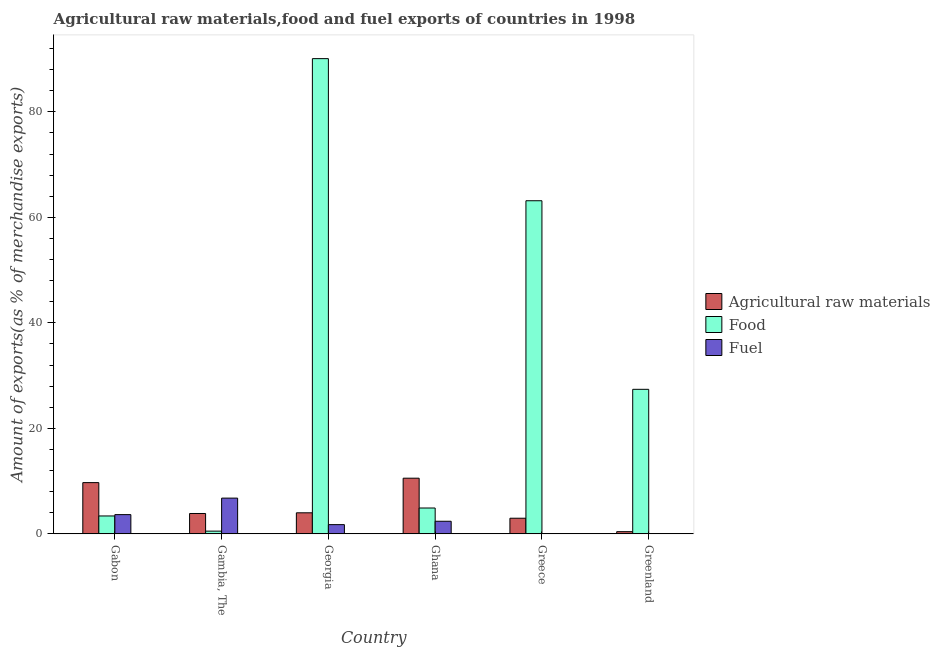Are the number of bars per tick equal to the number of legend labels?
Your answer should be very brief. Yes. Are the number of bars on each tick of the X-axis equal?
Your response must be concise. Yes. How many bars are there on the 4th tick from the left?
Provide a short and direct response. 3. What is the label of the 1st group of bars from the left?
Make the answer very short. Gabon. What is the percentage of raw materials exports in Gabon?
Provide a short and direct response. 9.71. Across all countries, what is the maximum percentage of raw materials exports?
Give a very brief answer. 10.55. Across all countries, what is the minimum percentage of food exports?
Keep it short and to the point. 0.52. In which country was the percentage of fuel exports maximum?
Offer a very short reply. Gambia, The. In which country was the percentage of raw materials exports minimum?
Offer a terse response. Greenland. What is the total percentage of raw materials exports in the graph?
Offer a very short reply. 31.5. What is the difference between the percentage of raw materials exports in Greece and that in Greenland?
Your answer should be very brief. 2.55. What is the difference between the percentage of fuel exports in Gambia, The and the percentage of food exports in Greece?
Offer a very short reply. -56.37. What is the average percentage of raw materials exports per country?
Ensure brevity in your answer.  5.25. What is the difference between the percentage of food exports and percentage of fuel exports in Greece?
Your response must be concise. 63.13. In how many countries, is the percentage of fuel exports greater than 4 %?
Give a very brief answer. 1. What is the ratio of the percentage of food exports in Georgia to that in Greece?
Your answer should be very brief. 1.43. Is the percentage of raw materials exports in Gabon less than that in Greenland?
Ensure brevity in your answer.  No. What is the difference between the highest and the second highest percentage of raw materials exports?
Provide a succinct answer. 0.84. What is the difference between the highest and the lowest percentage of food exports?
Your answer should be compact. 89.56. Is the sum of the percentage of fuel exports in Gabon and Greenland greater than the maximum percentage of food exports across all countries?
Your answer should be very brief. No. What does the 2nd bar from the left in Gabon represents?
Ensure brevity in your answer.  Food. What does the 1st bar from the right in Greece represents?
Your response must be concise. Fuel. Is it the case that in every country, the sum of the percentage of raw materials exports and percentage of food exports is greater than the percentage of fuel exports?
Provide a succinct answer. No. How many bars are there?
Offer a terse response. 18. How many countries are there in the graph?
Provide a succinct answer. 6. Are the values on the major ticks of Y-axis written in scientific E-notation?
Your answer should be compact. No. Does the graph contain any zero values?
Your response must be concise. No. How are the legend labels stacked?
Provide a succinct answer. Vertical. What is the title of the graph?
Your response must be concise. Agricultural raw materials,food and fuel exports of countries in 1998. Does "Other sectors" appear as one of the legend labels in the graph?
Provide a short and direct response. No. What is the label or title of the X-axis?
Give a very brief answer. Country. What is the label or title of the Y-axis?
Your response must be concise. Amount of exports(as % of merchandise exports). What is the Amount of exports(as % of merchandise exports) in Agricultural raw materials in Gabon?
Keep it short and to the point. 9.71. What is the Amount of exports(as % of merchandise exports) in Food in Gabon?
Your answer should be compact. 3.39. What is the Amount of exports(as % of merchandise exports) of Fuel in Gabon?
Provide a short and direct response. 3.65. What is the Amount of exports(as % of merchandise exports) of Agricultural raw materials in Gambia, The?
Your answer should be compact. 3.86. What is the Amount of exports(as % of merchandise exports) in Food in Gambia, The?
Make the answer very short. 0.52. What is the Amount of exports(as % of merchandise exports) of Fuel in Gambia, The?
Give a very brief answer. 6.78. What is the Amount of exports(as % of merchandise exports) of Agricultural raw materials in Georgia?
Make the answer very short. 3.99. What is the Amount of exports(as % of merchandise exports) in Food in Georgia?
Give a very brief answer. 90.08. What is the Amount of exports(as % of merchandise exports) in Fuel in Georgia?
Give a very brief answer. 1.75. What is the Amount of exports(as % of merchandise exports) in Agricultural raw materials in Ghana?
Offer a very short reply. 10.55. What is the Amount of exports(as % of merchandise exports) in Food in Ghana?
Offer a terse response. 4.9. What is the Amount of exports(as % of merchandise exports) of Fuel in Ghana?
Make the answer very short. 2.39. What is the Amount of exports(as % of merchandise exports) in Agricultural raw materials in Greece?
Provide a short and direct response. 2.96. What is the Amount of exports(as % of merchandise exports) in Food in Greece?
Provide a succinct answer. 63.14. What is the Amount of exports(as % of merchandise exports) of Fuel in Greece?
Ensure brevity in your answer.  0.01. What is the Amount of exports(as % of merchandise exports) in Agricultural raw materials in Greenland?
Provide a short and direct response. 0.42. What is the Amount of exports(as % of merchandise exports) in Food in Greenland?
Provide a short and direct response. 27.4. What is the Amount of exports(as % of merchandise exports) of Fuel in Greenland?
Offer a terse response. 0.06. Across all countries, what is the maximum Amount of exports(as % of merchandise exports) in Agricultural raw materials?
Offer a very short reply. 10.55. Across all countries, what is the maximum Amount of exports(as % of merchandise exports) in Food?
Your answer should be compact. 90.08. Across all countries, what is the maximum Amount of exports(as % of merchandise exports) of Fuel?
Ensure brevity in your answer.  6.78. Across all countries, what is the minimum Amount of exports(as % of merchandise exports) in Agricultural raw materials?
Your answer should be compact. 0.42. Across all countries, what is the minimum Amount of exports(as % of merchandise exports) of Food?
Your answer should be very brief. 0.52. Across all countries, what is the minimum Amount of exports(as % of merchandise exports) in Fuel?
Your response must be concise. 0.01. What is the total Amount of exports(as % of merchandise exports) of Agricultural raw materials in the graph?
Your answer should be very brief. 31.5. What is the total Amount of exports(as % of merchandise exports) in Food in the graph?
Your answer should be compact. 189.43. What is the total Amount of exports(as % of merchandise exports) of Fuel in the graph?
Offer a very short reply. 14.63. What is the difference between the Amount of exports(as % of merchandise exports) in Agricultural raw materials in Gabon and that in Gambia, The?
Your answer should be compact. 5.85. What is the difference between the Amount of exports(as % of merchandise exports) in Food in Gabon and that in Gambia, The?
Your answer should be compact. 2.88. What is the difference between the Amount of exports(as % of merchandise exports) of Fuel in Gabon and that in Gambia, The?
Your answer should be very brief. -3.13. What is the difference between the Amount of exports(as % of merchandise exports) of Agricultural raw materials in Gabon and that in Georgia?
Your answer should be compact. 5.72. What is the difference between the Amount of exports(as % of merchandise exports) in Food in Gabon and that in Georgia?
Offer a very short reply. -86.69. What is the difference between the Amount of exports(as % of merchandise exports) in Fuel in Gabon and that in Georgia?
Your response must be concise. 1.9. What is the difference between the Amount of exports(as % of merchandise exports) in Agricultural raw materials in Gabon and that in Ghana?
Offer a very short reply. -0.84. What is the difference between the Amount of exports(as % of merchandise exports) of Food in Gabon and that in Ghana?
Your answer should be very brief. -1.51. What is the difference between the Amount of exports(as % of merchandise exports) in Fuel in Gabon and that in Ghana?
Offer a very short reply. 1.26. What is the difference between the Amount of exports(as % of merchandise exports) in Agricultural raw materials in Gabon and that in Greece?
Provide a succinct answer. 6.75. What is the difference between the Amount of exports(as % of merchandise exports) in Food in Gabon and that in Greece?
Offer a terse response. -59.75. What is the difference between the Amount of exports(as % of merchandise exports) of Fuel in Gabon and that in Greece?
Your answer should be very brief. 3.63. What is the difference between the Amount of exports(as % of merchandise exports) in Agricultural raw materials in Gabon and that in Greenland?
Offer a very short reply. 9.3. What is the difference between the Amount of exports(as % of merchandise exports) of Food in Gabon and that in Greenland?
Your answer should be very brief. -24. What is the difference between the Amount of exports(as % of merchandise exports) in Fuel in Gabon and that in Greenland?
Provide a short and direct response. 3.59. What is the difference between the Amount of exports(as % of merchandise exports) of Agricultural raw materials in Gambia, The and that in Georgia?
Keep it short and to the point. -0.13. What is the difference between the Amount of exports(as % of merchandise exports) of Food in Gambia, The and that in Georgia?
Provide a succinct answer. -89.56. What is the difference between the Amount of exports(as % of merchandise exports) in Fuel in Gambia, The and that in Georgia?
Provide a succinct answer. 5.03. What is the difference between the Amount of exports(as % of merchandise exports) of Agricultural raw materials in Gambia, The and that in Ghana?
Ensure brevity in your answer.  -6.69. What is the difference between the Amount of exports(as % of merchandise exports) in Food in Gambia, The and that in Ghana?
Your response must be concise. -4.39. What is the difference between the Amount of exports(as % of merchandise exports) of Fuel in Gambia, The and that in Ghana?
Give a very brief answer. 4.39. What is the difference between the Amount of exports(as % of merchandise exports) of Agricultural raw materials in Gambia, The and that in Greece?
Your answer should be compact. 0.9. What is the difference between the Amount of exports(as % of merchandise exports) in Food in Gambia, The and that in Greece?
Keep it short and to the point. -62.63. What is the difference between the Amount of exports(as % of merchandise exports) in Fuel in Gambia, The and that in Greece?
Your answer should be compact. 6.76. What is the difference between the Amount of exports(as % of merchandise exports) in Agricultural raw materials in Gambia, The and that in Greenland?
Ensure brevity in your answer.  3.45. What is the difference between the Amount of exports(as % of merchandise exports) in Food in Gambia, The and that in Greenland?
Keep it short and to the point. -26.88. What is the difference between the Amount of exports(as % of merchandise exports) in Fuel in Gambia, The and that in Greenland?
Your response must be concise. 6.72. What is the difference between the Amount of exports(as % of merchandise exports) of Agricultural raw materials in Georgia and that in Ghana?
Your response must be concise. -6.56. What is the difference between the Amount of exports(as % of merchandise exports) of Food in Georgia and that in Ghana?
Ensure brevity in your answer.  85.18. What is the difference between the Amount of exports(as % of merchandise exports) in Fuel in Georgia and that in Ghana?
Your response must be concise. -0.64. What is the difference between the Amount of exports(as % of merchandise exports) in Agricultural raw materials in Georgia and that in Greece?
Your answer should be compact. 1.03. What is the difference between the Amount of exports(as % of merchandise exports) of Food in Georgia and that in Greece?
Provide a short and direct response. 26.94. What is the difference between the Amount of exports(as % of merchandise exports) of Fuel in Georgia and that in Greece?
Provide a succinct answer. 1.74. What is the difference between the Amount of exports(as % of merchandise exports) in Agricultural raw materials in Georgia and that in Greenland?
Your answer should be very brief. 3.58. What is the difference between the Amount of exports(as % of merchandise exports) in Food in Georgia and that in Greenland?
Your answer should be very brief. 62.68. What is the difference between the Amount of exports(as % of merchandise exports) in Fuel in Georgia and that in Greenland?
Your answer should be compact. 1.69. What is the difference between the Amount of exports(as % of merchandise exports) of Agricultural raw materials in Ghana and that in Greece?
Your answer should be compact. 7.59. What is the difference between the Amount of exports(as % of merchandise exports) of Food in Ghana and that in Greece?
Keep it short and to the point. -58.24. What is the difference between the Amount of exports(as % of merchandise exports) of Fuel in Ghana and that in Greece?
Your response must be concise. 2.37. What is the difference between the Amount of exports(as % of merchandise exports) of Agricultural raw materials in Ghana and that in Greenland?
Make the answer very short. 10.13. What is the difference between the Amount of exports(as % of merchandise exports) in Food in Ghana and that in Greenland?
Your response must be concise. -22.5. What is the difference between the Amount of exports(as % of merchandise exports) of Fuel in Ghana and that in Greenland?
Give a very brief answer. 2.33. What is the difference between the Amount of exports(as % of merchandise exports) of Agricultural raw materials in Greece and that in Greenland?
Make the answer very short. 2.55. What is the difference between the Amount of exports(as % of merchandise exports) of Food in Greece and that in Greenland?
Keep it short and to the point. 35.75. What is the difference between the Amount of exports(as % of merchandise exports) of Fuel in Greece and that in Greenland?
Give a very brief answer. -0.04. What is the difference between the Amount of exports(as % of merchandise exports) in Agricultural raw materials in Gabon and the Amount of exports(as % of merchandise exports) in Food in Gambia, The?
Your answer should be compact. 9.2. What is the difference between the Amount of exports(as % of merchandise exports) of Agricultural raw materials in Gabon and the Amount of exports(as % of merchandise exports) of Fuel in Gambia, The?
Offer a terse response. 2.94. What is the difference between the Amount of exports(as % of merchandise exports) in Food in Gabon and the Amount of exports(as % of merchandise exports) in Fuel in Gambia, The?
Provide a succinct answer. -3.38. What is the difference between the Amount of exports(as % of merchandise exports) of Agricultural raw materials in Gabon and the Amount of exports(as % of merchandise exports) of Food in Georgia?
Provide a short and direct response. -80.37. What is the difference between the Amount of exports(as % of merchandise exports) of Agricultural raw materials in Gabon and the Amount of exports(as % of merchandise exports) of Fuel in Georgia?
Give a very brief answer. 7.96. What is the difference between the Amount of exports(as % of merchandise exports) in Food in Gabon and the Amount of exports(as % of merchandise exports) in Fuel in Georgia?
Ensure brevity in your answer.  1.64. What is the difference between the Amount of exports(as % of merchandise exports) in Agricultural raw materials in Gabon and the Amount of exports(as % of merchandise exports) in Food in Ghana?
Ensure brevity in your answer.  4.81. What is the difference between the Amount of exports(as % of merchandise exports) in Agricultural raw materials in Gabon and the Amount of exports(as % of merchandise exports) in Fuel in Ghana?
Provide a succinct answer. 7.32. What is the difference between the Amount of exports(as % of merchandise exports) in Food in Gabon and the Amount of exports(as % of merchandise exports) in Fuel in Ghana?
Your answer should be very brief. 1. What is the difference between the Amount of exports(as % of merchandise exports) of Agricultural raw materials in Gabon and the Amount of exports(as % of merchandise exports) of Food in Greece?
Provide a short and direct response. -53.43. What is the difference between the Amount of exports(as % of merchandise exports) in Agricultural raw materials in Gabon and the Amount of exports(as % of merchandise exports) in Fuel in Greece?
Your answer should be compact. 9.7. What is the difference between the Amount of exports(as % of merchandise exports) in Food in Gabon and the Amount of exports(as % of merchandise exports) in Fuel in Greece?
Provide a short and direct response. 3.38. What is the difference between the Amount of exports(as % of merchandise exports) of Agricultural raw materials in Gabon and the Amount of exports(as % of merchandise exports) of Food in Greenland?
Your response must be concise. -17.68. What is the difference between the Amount of exports(as % of merchandise exports) of Agricultural raw materials in Gabon and the Amount of exports(as % of merchandise exports) of Fuel in Greenland?
Provide a short and direct response. 9.66. What is the difference between the Amount of exports(as % of merchandise exports) in Food in Gabon and the Amount of exports(as % of merchandise exports) in Fuel in Greenland?
Ensure brevity in your answer.  3.34. What is the difference between the Amount of exports(as % of merchandise exports) of Agricultural raw materials in Gambia, The and the Amount of exports(as % of merchandise exports) of Food in Georgia?
Give a very brief answer. -86.22. What is the difference between the Amount of exports(as % of merchandise exports) of Agricultural raw materials in Gambia, The and the Amount of exports(as % of merchandise exports) of Fuel in Georgia?
Give a very brief answer. 2.11. What is the difference between the Amount of exports(as % of merchandise exports) of Food in Gambia, The and the Amount of exports(as % of merchandise exports) of Fuel in Georgia?
Keep it short and to the point. -1.23. What is the difference between the Amount of exports(as % of merchandise exports) in Agricultural raw materials in Gambia, The and the Amount of exports(as % of merchandise exports) in Food in Ghana?
Offer a terse response. -1.04. What is the difference between the Amount of exports(as % of merchandise exports) of Agricultural raw materials in Gambia, The and the Amount of exports(as % of merchandise exports) of Fuel in Ghana?
Provide a succinct answer. 1.47. What is the difference between the Amount of exports(as % of merchandise exports) of Food in Gambia, The and the Amount of exports(as % of merchandise exports) of Fuel in Ghana?
Make the answer very short. -1.87. What is the difference between the Amount of exports(as % of merchandise exports) of Agricultural raw materials in Gambia, The and the Amount of exports(as % of merchandise exports) of Food in Greece?
Your response must be concise. -59.28. What is the difference between the Amount of exports(as % of merchandise exports) of Agricultural raw materials in Gambia, The and the Amount of exports(as % of merchandise exports) of Fuel in Greece?
Keep it short and to the point. 3.85. What is the difference between the Amount of exports(as % of merchandise exports) in Food in Gambia, The and the Amount of exports(as % of merchandise exports) in Fuel in Greece?
Your response must be concise. 0.5. What is the difference between the Amount of exports(as % of merchandise exports) of Agricultural raw materials in Gambia, The and the Amount of exports(as % of merchandise exports) of Food in Greenland?
Your response must be concise. -23.54. What is the difference between the Amount of exports(as % of merchandise exports) in Agricultural raw materials in Gambia, The and the Amount of exports(as % of merchandise exports) in Fuel in Greenland?
Your answer should be compact. 3.81. What is the difference between the Amount of exports(as % of merchandise exports) in Food in Gambia, The and the Amount of exports(as % of merchandise exports) in Fuel in Greenland?
Give a very brief answer. 0.46. What is the difference between the Amount of exports(as % of merchandise exports) of Agricultural raw materials in Georgia and the Amount of exports(as % of merchandise exports) of Food in Ghana?
Your answer should be very brief. -0.91. What is the difference between the Amount of exports(as % of merchandise exports) of Agricultural raw materials in Georgia and the Amount of exports(as % of merchandise exports) of Fuel in Ghana?
Your response must be concise. 1.6. What is the difference between the Amount of exports(as % of merchandise exports) of Food in Georgia and the Amount of exports(as % of merchandise exports) of Fuel in Ghana?
Your answer should be compact. 87.69. What is the difference between the Amount of exports(as % of merchandise exports) in Agricultural raw materials in Georgia and the Amount of exports(as % of merchandise exports) in Food in Greece?
Keep it short and to the point. -59.15. What is the difference between the Amount of exports(as % of merchandise exports) of Agricultural raw materials in Georgia and the Amount of exports(as % of merchandise exports) of Fuel in Greece?
Your answer should be very brief. 3.98. What is the difference between the Amount of exports(as % of merchandise exports) in Food in Georgia and the Amount of exports(as % of merchandise exports) in Fuel in Greece?
Give a very brief answer. 90.07. What is the difference between the Amount of exports(as % of merchandise exports) in Agricultural raw materials in Georgia and the Amount of exports(as % of merchandise exports) in Food in Greenland?
Your answer should be compact. -23.41. What is the difference between the Amount of exports(as % of merchandise exports) in Agricultural raw materials in Georgia and the Amount of exports(as % of merchandise exports) in Fuel in Greenland?
Give a very brief answer. 3.93. What is the difference between the Amount of exports(as % of merchandise exports) in Food in Georgia and the Amount of exports(as % of merchandise exports) in Fuel in Greenland?
Your answer should be very brief. 90.02. What is the difference between the Amount of exports(as % of merchandise exports) in Agricultural raw materials in Ghana and the Amount of exports(as % of merchandise exports) in Food in Greece?
Ensure brevity in your answer.  -52.59. What is the difference between the Amount of exports(as % of merchandise exports) in Agricultural raw materials in Ghana and the Amount of exports(as % of merchandise exports) in Fuel in Greece?
Your answer should be very brief. 10.54. What is the difference between the Amount of exports(as % of merchandise exports) of Food in Ghana and the Amount of exports(as % of merchandise exports) of Fuel in Greece?
Your answer should be compact. 4.89. What is the difference between the Amount of exports(as % of merchandise exports) of Agricultural raw materials in Ghana and the Amount of exports(as % of merchandise exports) of Food in Greenland?
Ensure brevity in your answer.  -16.85. What is the difference between the Amount of exports(as % of merchandise exports) in Agricultural raw materials in Ghana and the Amount of exports(as % of merchandise exports) in Fuel in Greenland?
Keep it short and to the point. 10.49. What is the difference between the Amount of exports(as % of merchandise exports) in Food in Ghana and the Amount of exports(as % of merchandise exports) in Fuel in Greenland?
Offer a very short reply. 4.85. What is the difference between the Amount of exports(as % of merchandise exports) in Agricultural raw materials in Greece and the Amount of exports(as % of merchandise exports) in Food in Greenland?
Make the answer very short. -24.43. What is the difference between the Amount of exports(as % of merchandise exports) of Agricultural raw materials in Greece and the Amount of exports(as % of merchandise exports) of Fuel in Greenland?
Provide a succinct answer. 2.91. What is the difference between the Amount of exports(as % of merchandise exports) in Food in Greece and the Amount of exports(as % of merchandise exports) in Fuel in Greenland?
Provide a succinct answer. 63.09. What is the average Amount of exports(as % of merchandise exports) in Agricultural raw materials per country?
Provide a short and direct response. 5.25. What is the average Amount of exports(as % of merchandise exports) in Food per country?
Keep it short and to the point. 31.57. What is the average Amount of exports(as % of merchandise exports) of Fuel per country?
Your response must be concise. 2.44. What is the difference between the Amount of exports(as % of merchandise exports) in Agricultural raw materials and Amount of exports(as % of merchandise exports) in Food in Gabon?
Offer a terse response. 6.32. What is the difference between the Amount of exports(as % of merchandise exports) of Agricultural raw materials and Amount of exports(as % of merchandise exports) of Fuel in Gabon?
Offer a very short reply. 6.07. What is the difference between the Amount of exports(as % of merchandise exports) of Food and Amount of exports(as % of merchandise exports) of Fuel in Gabon?
Provide a succinct answer. -0.25. What is the difference between the Amount of exports(as % of merchandise exports) in Agricultural raw materials and Amount of exports(as % of merchandise exports) in Food in Gambia, The?
Ensure brevity in your answer.  3.35. What is the difference between the Amount of exports(as % of merchandise exports) of Agricultural raw materials and Amount of exports(as % of merchandise exports) of Fuel in Gambia, The?
Provide a short and direct response. -2.91. What is the difference between the Amount of exports(as % of merchandise exports) of Food and Amount of exports(as % of merchandise exports) of Fuel in Gambia, The?
Offer a terse response. -6.26. What is the difference between the Amount of exports(as % of merchandise exports) of Agricultural raw materials and Amount of exports(as % of merchandise exports) of Food in Georgia?
Offer a terse response. -86.09. What is the difference between the Amount of exports(as % of merchandise exports) in Agricultural raw materials and Amount of exports(as % of merchandise exports) in Fuel in Georgia?
Provide a succinct answer. 2.24. What is the difference between the Amount of exports(as % of merchandise exports) in Food and Amount of exports(as % of merchandise exports) in Fuel in Georgia?
Make the answer very short. 88.33. What is the difference between the Amount of exports(as % of merchandise exports) in Agricultural raw materials and Amount of exports(as % of merchandise exports) in Food in Ghana?
Ensure brevity in your answer.  5.65. What is the difference between the Amount of exports(as % of merchandise exports) of Agricultural raw materials and Amount of exports(as % of merchandise exports) of Fuel in Ghana?
Provide a succinct answer. 8.16. What is the difference between the Amount of exports(as % of merchandise exports) of Food and Amount of exports(as % of merchandise exports) of Fuel in Ghana?
Make the answer very short. 2.51. What is the difference between the Amount of exports(as % of merchandise exports) of Agricultural raw materials and Amount of exports(as % of merchandise exports) of Food in Greece?
Offer a terse response. -60.18. What is the difference between the Amount of exports(as % of merchandise exports) in Agricultural raw materials and Amount of exports(as % of merchandise exports) in Fuel in Greece?
Provide a short and direct response. 2.95. What is the difference between the Amount of exports(as % of merchandise exports) of Food and Amount of exports(as % of merchandise exports) of Fuel in Greece?
Give a very brief answer. 63.13. What is the difference between the Amount of exports(as % of merchandise exports) of Agricultural raw materials and Amount of exports(as % of merchandise exports) of Food in Greenland?
Your response must be concise. -26.98. What is the difference between the Amount of exports(as % of merchandise exports) in Agricultural raw materials and Amount of exports(as % of merchandise exports) in Fuel in Greenland?
Ensure brevity in your answer.  0.36. What is the difference between the Amount of exports(as % of merchandise exports) of Food and Amount of exports(as % of merchandise exports) of Fuel in Greenland?
Your answer should be compact. 27.34. What is the ratio of the Amount of exports(as % of merchandise exports) of Agricultural raw materials in Gabon to that in Gambia, The?
Offer a terse response. 2.52. What is the ratio of the Amount of exports(as % of merchandise exports) in Food in Gabon to that in Gambia, The?
Keep it short and to the point. 6.58. What is the ratio of the Amount of exports(as % of merchandise exports) in Fuel in Gabon to that in Gambia, The?
Provide a short and direct response. 0.54. What is the ratio of the Amount of exports(as % of merchandise exports) of Agricultural raw materials in Gabon to that in Georgia?
Keep it short and to the point. 2.43. What is the ratio of the Amount of exports(as % of merchandise exports) in Food in Gabon to that in Georgia?
Make the answer very short. 0.04. What is the ratio of the Amount of exports(as % of merchandise exports) in Fuel in Gabon to that in Georgia?
Keep it short and to the point. 2.08. What is the ratio of the Amount of exports(as % of merchandise exports) in Agricultural raw materials in Gabon to that in Ghana?
Your answer should be very brief. 0.92. What is the ratio of the Amount of exports(as % of merchandise exports) in Food in Gabon to that in Ghana?
Your answer should be compact. 0.69. What is the ratio of the Amount of exports(as % of merchandise exports) in Fuel in Gabon to that in Ghana?
Your answer should be compact. 1.53. What is the ratio of the Amount of exports(as % of merchandise exports) in Agricultural raw materials in Gabon to that in Greece?
Offer a terse response. 3.28. What is the ratio of the Amount of exports(as % of merchandise exports) in Food in Gabon to that in Greece?
Give a very brief answer. 0.05. What is the ratio of the Amount of exports(as % of merchandise exports) in Fuel in Gabon to that in Greece?
Provide a short and direct response. 267.36. What is the ratio of the Amount of exports(as % of merchandise exports) in Agricultural raw materials in Gabon to that in Greenland?
Your response must be concise. 23.37. What is the ratio of the Amount of exports(as % of merchandise exports) of Food in Gabon to that in Greenland?
Your answer should be compact. 0.12. What is the ratio of the Amount of exports(as % of merchandise exports) of Fuel in Gabon to that in Greenland?
Your response must be concise. 64.36. What is the ratio of the Amount of exports(as % of merchandise exports) of Agricultural raw materials in Gambia, The to that in Georgia?
Offer a terse response. 0.97. What is the ratio of the Amount of exports(as % of merchandise exports) of Food in Gambia, The to that in Georgia?
Offer a terse response. 0.01. What is the ratio of the Amount of exports(as % of merchandise exports) of Fuel in Gambia, The to that in Georgia?
Offer a very short reply. 3.87. What is the ratio of the Amount of exports(as % of merchandise exports) in Agricultural raw materials in Gambia, The to that in Ghana?
Offer a terse response. 0.37. What is the ratio of the Amount of exports(as % of merchandise exports) in Food in Gambia, The to that in Ghana?
Give a very brief answer. 0.11. What is the ratio of the Amount of exports(as % of merchandise exports) in Fuel in Gambia, The to that in Ghana?
Ensure brevity in your answer.  2.84. What is the ratio of the Amount of exports(as % of merchandise exports) of Agricultural raw materials in Gambia, The to that in Greece?
Offer a very short reply. 1.3. What is the ratio of the Amount of exports(as % of merchandise exports) of Food in Gambia, The to that in Greece?
Ensure brevity in your answer.  0.01. What is the ratio of the Amount of exports(as % of merchandise exports) of Fuel in Gambia, The to that in Greece?
Keep it short and to the point. 496.8. What is the ratio of the Amount of exports(as % of merchandise exports) in Agricultural raw materials in Gambia, The to that in Greenland?
Make the answer very short. 9.29. What is the ratio of the Amount of exports(as % of merchandise exports) in Food in Gambia, The to that in Greenland?
Provide a short and direct response. 0.02. What is the ratio of the Amount of exports(as % of merchandise exports) in Fuel in Gambia, The to that in Greenland?
Give a very brief answer. 119.6. What is the ratio of the Amount of exports(as % of merchandise exports) in Agricultural raw materials in Georgia to that in Ghana?
Your response must be concise. 0.38. What is the ratio of the Amount of exports(as % of merchandise exports) in Food in Georgia to that in Ghana?
Your answer should be compact. 18.38. What is the ratio of the Amount of exports(as % of merchandise exports) in Fuel in Georgia to that in Ghana?
Provide a short and direct response. 0.73. What is the ratio of the Amount of exports(as % of merchandise exports) of Agricultural raw materials in Georgia to that in Greece?
Offer a very short reply. 1.35. What is the ratio of the Amount of exports(as % of merchandise exports) of Food in Georgia to that in Greece?
Your answer should be compact. 1.43. What is the ratio of the Amount of exports(as % of merchandise exports) in Fuel in Georgia to that in Greece?
Ensure brevity in your answer.  128.35. What is the ratio of the Amount of exports(as % of merchandise exports) in Agricultural raw materials in Georgia to that in Greenland?
Your response must be concise. 9.6. What is the ratio of the Amount of exports(as % of merchandise exports) of Food in Georgia to that in Greenland?
Provide a short and direct response. 3.29. What is the ratio of the Amount of exports(as % of merchandise exports) in Fuel in Georgia to that in Greenland?
Your answer should be very brief. 30.9. What is the ratio of the Amount of exports(as % of merchandise exports) in Agricultural raw materials in Ghana to that in Greece?
Offer a terse response. 3.56. What is the ratio of the Amount of exports(as % of merchandise exports) in Food in Ghana to that in Greece?
Give a very brief answer. 0.08. What is the ratio of the Amount of exports(as % of merchandise exports) of Fuel in Ghana to that in Greece?
Keep it short and to the point. 175.06. What is the ratio of the Amount of exports(as % of merchandise exports) in Agricultural raw materials in Ghana to that in Greenland?
Provide a succinct answer. 25.38. What is the ratio of the Amount of exports(as % of merchandise exports) of Food in Ghana to that in Greenland?
Your response must be concise. 0.18. What is the ratio of the Amount of exports(as % of merchandise exports) of Fuel in Ghana to that in Greenland?
Keep it short and to the point. 42.14. What is the ratio of the Amount of exports(as % of merchandise exports) in Agricultural raw materials in Greece to that in Greenland?
Provide a short and direct response. 7.13. What is the ratio of the Amount of exports(as % of merchandise exports) in Food in Greece to that in Greenland?
Your answer should be very brief. 2.3. What is the ratio of the Amount of exports(as % of merchandise exports) of Fuel in Greece to that in Greenland?
Your response must be concise. 0.24. What is the difference between the highest and the second highest Amount of exports(as % of merchandise exports) of Agricultural raw materials?
Ensure brevity in your answer.  0.84. What is the difference between the highest and the second highest Amount of exports(as % of merchandise exports) of Food?
Provide a short and direct response. 26.94. What is the difference between the highest and the second highest Amount of exports(as % of merchandise exports) of Fuel?
Your answer should be compact. 3.13. What is the difference between the highest and the lowest Amount of exports(as % of merchandise exports) of Agricultural raw materials?
Offer a very short reply. 10.13. What is the difference between the highest and the lowest Amount of exports(as % of merchandise exports) of Food?
Your response must be concise. 89.56. What is the difference between the highest and the lowest Amount of exports(as % of merchandise exports) in Fuel?
Make the answer very short. 6.76. 